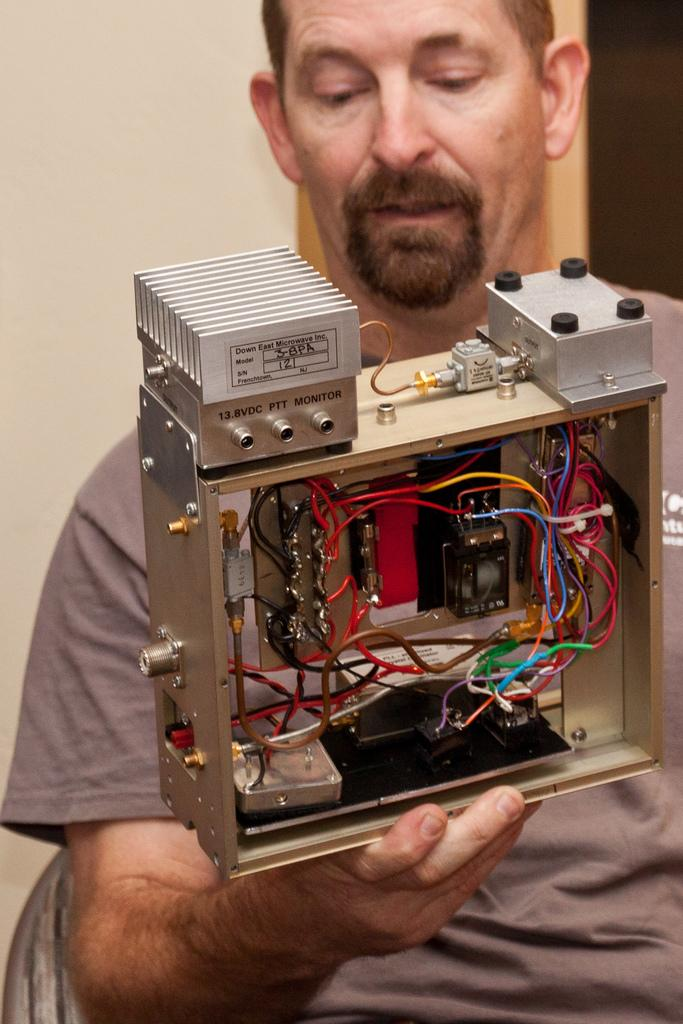Who is present in the image? There is a man in the image. What is the man doing in the image? The man is sitting on a chair in the image. What is the man holding in the image? The man is holding an electrical equipment in the image. What can be seen in the background of the image? There is a wall in the background of the image, and the background is black in color. What type of goat can be seen in the image? There is no goat present in the image. What is the man using to stir the electrical equipment in the image? The man is not stirring the electrical equipment in the image, and there is no spoon present. 